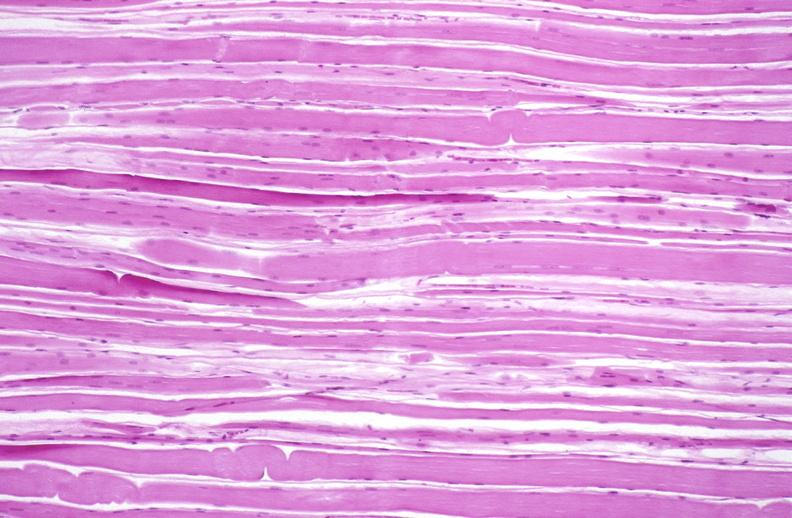what does this image show?
Answer the question using a single word or phrase. Skeletal muscle atrophy 